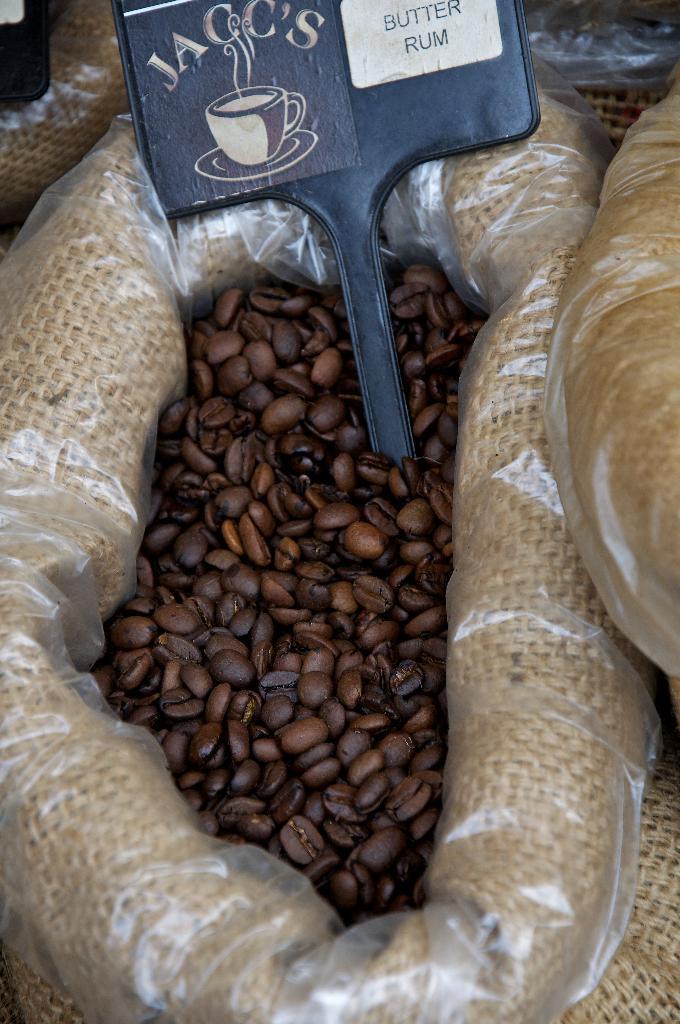How would you summarize this image in a sentence or two? In this image there are coffee beans in a bag. On top of the coffee beans there is a name board. Beside the bag there are a few other bags. 